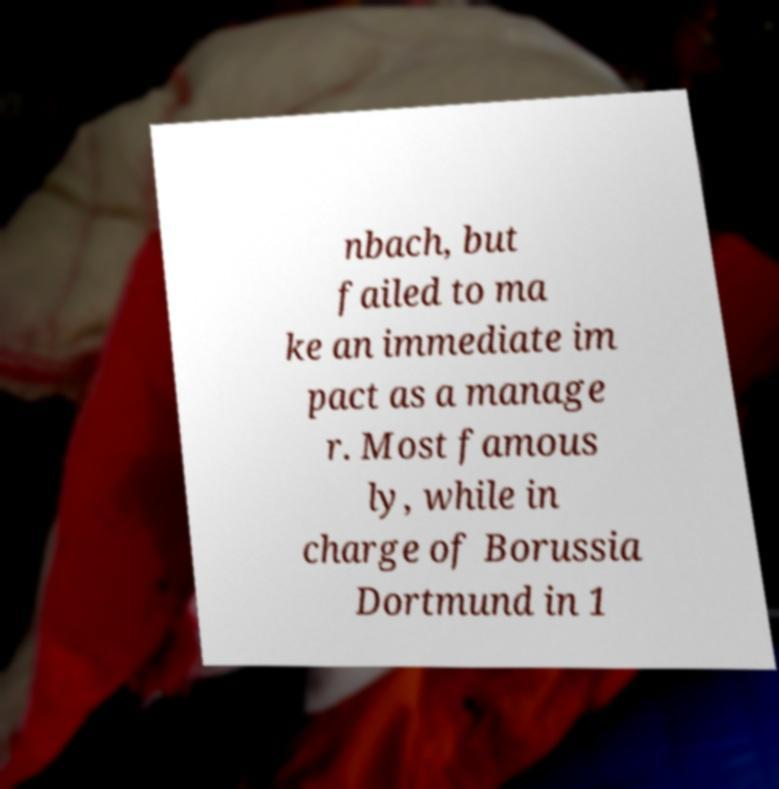Please read and relay the text visible in this image. What does it say? nbach, but failed to ma ke an immediate im pact as a manage r. Most famous ly, while in charge of Borussia Dortmund in 1 